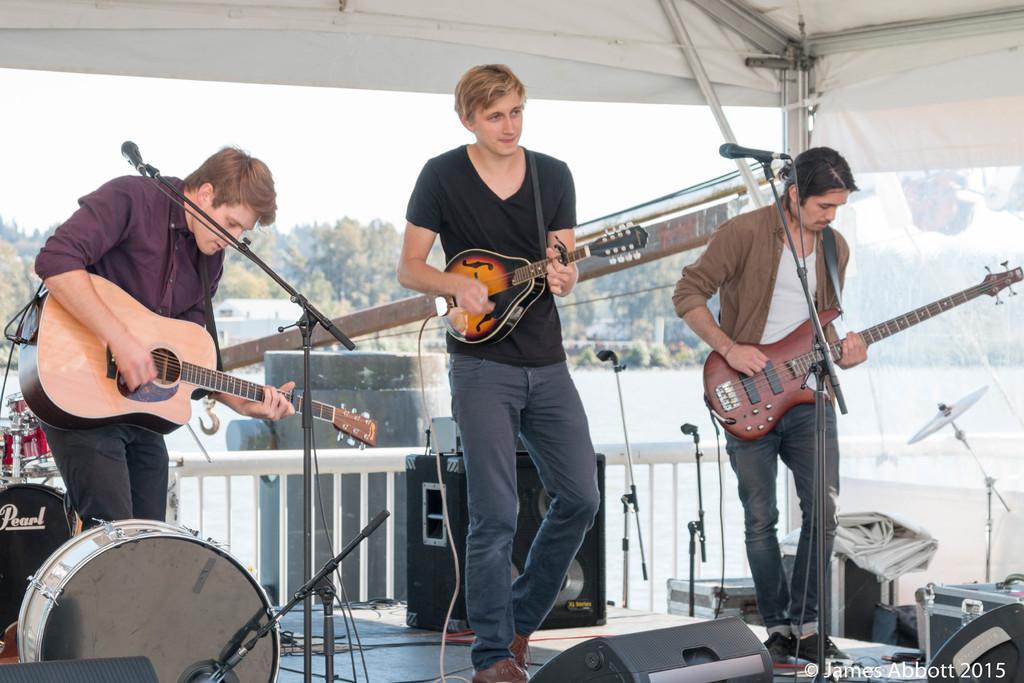In one or two sentences, can you explain what this image depicts? In this picture there were three persons performing on the stage. All of them are holding guitars. In the middle, he is wearing black T shirt, blue jeans and brown shoes. In the right side he is wearing brown shirt, blue jeans, black shoes. In the left, person is wearing maroon shirt, black jeans. There is a drum before him. In the background, there were trees and blue sky. 